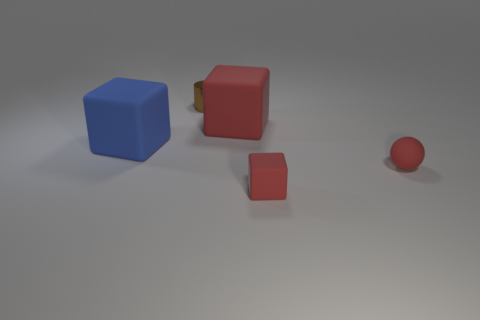What number of brown metal objects are the same size as the red matte ball?
Your answer should be compact. 1. What number of rubber objects are either cylinders or big gray cylinders?
Provide a short and direct response. 0. What material is the brown cylinder?
Offer a terse response. Metal. There is a big blue block; how many red rubber things are on the left side of it?
Your response must be concise. 0. Does the large block on the left side of the brown metallic cylinder have the same material as the tiny red sphere?
Provide a short and direct response. Yes. What number of other objects are the same shape as the blue matte object?
Make the answer very short. 2. How many large objects are either matte objects or shiny objects?
Make the answer very short. 2. There is a large rubber block that is behind the blue matte block; is its color the same as the tiny matte block?
Provide a short and direct response. Yes. There is a big cube that is to the right of the small brown object; does it have the same color as the block that is in front of the rubber ball?
Make the answer very short. Yes. Are there any big purple spheres made of the same material as the big red cube?
Offer a terse response. No. 